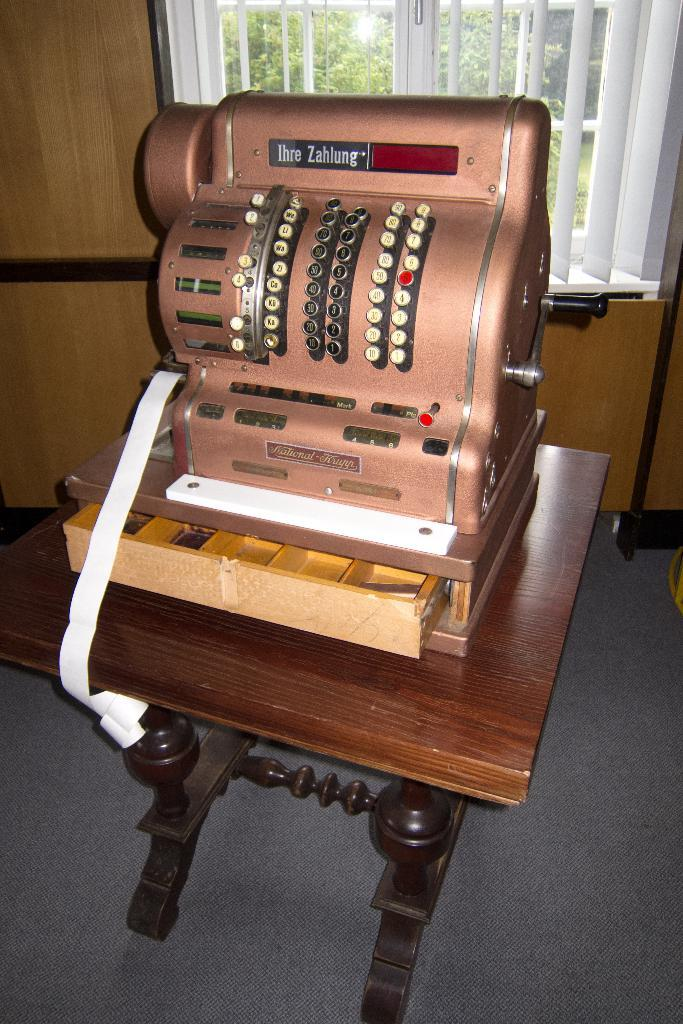What object is located on the table in the image? There is a machine on the table in the image. What is present on the wall in the image? There is a wall in the image, but no specific details about the wall are mentioned. What can be seen through the window in the image? Trees are visible through the window in the image. What type of truck is parked next to the machine in the image? There is no truck present in the image; only a machine, a wall, a window, and trees are visible. How many boxes are stacked on the table next to the machine in the image? There is no mention of any boxes in the image; only a machine is present on the table. 